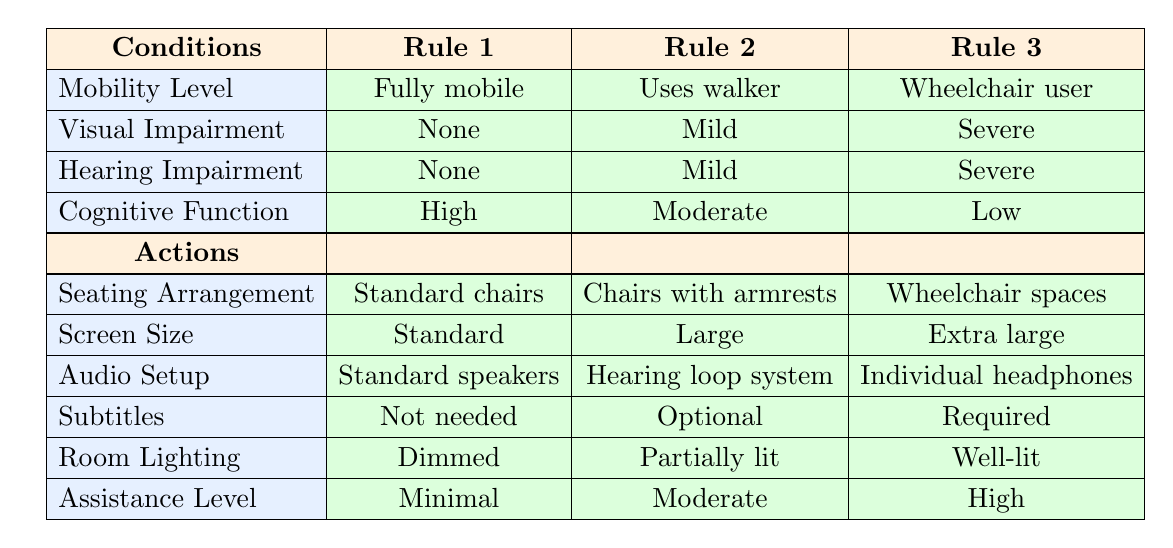What seating arrangement is recommended for individuals who are wheelchair users with severe visual and hearing impairment, and low cognitive function? According to Rule 3 in the table, for a wheelchair user with severe visual and hearing impairment, and low cognitive function, the recommended seating arrangement is "Wheelchair spaces."
Answer: Wheelchair spaces Is audio setup specified for individuals who are fully mobile and have high cognitive function? Yes, looking at Rule 1, the audio setup for fully mobile individuals with high cognitive function is "Standard speakers."
Answer: Yes What is the room lighting condition recommended for individuals who use walkers and have mild visual and hearing impairments, and moderate cognitive function? Referring to Rule 2, the room lighting condition for individuals who use walkers with mild visual and hearing impairments, and moderate cognitive function is "Partially lit."
Answer: Partially lit Can individuals who do not require subtitles be categorized as having high cognitive function? Yes, as seen in Rule 1, individuals with a mobility level of fully mobile, no visual or hearing impairment, and high cognitive function do not need subtitles.
Answer: Yes What is the difference in screen size recommended for those who are wheelchair users versus those who are fully mobile? From the table, Rule 3 specifies "Extra large" for wheelchair users while Rule 1 specifies "Standard" for fully mobile individuals. The difference is that wheelchair users have a larger screen size recommended compared to fully mobile individuals.
Answer: Extra large vs Standard 